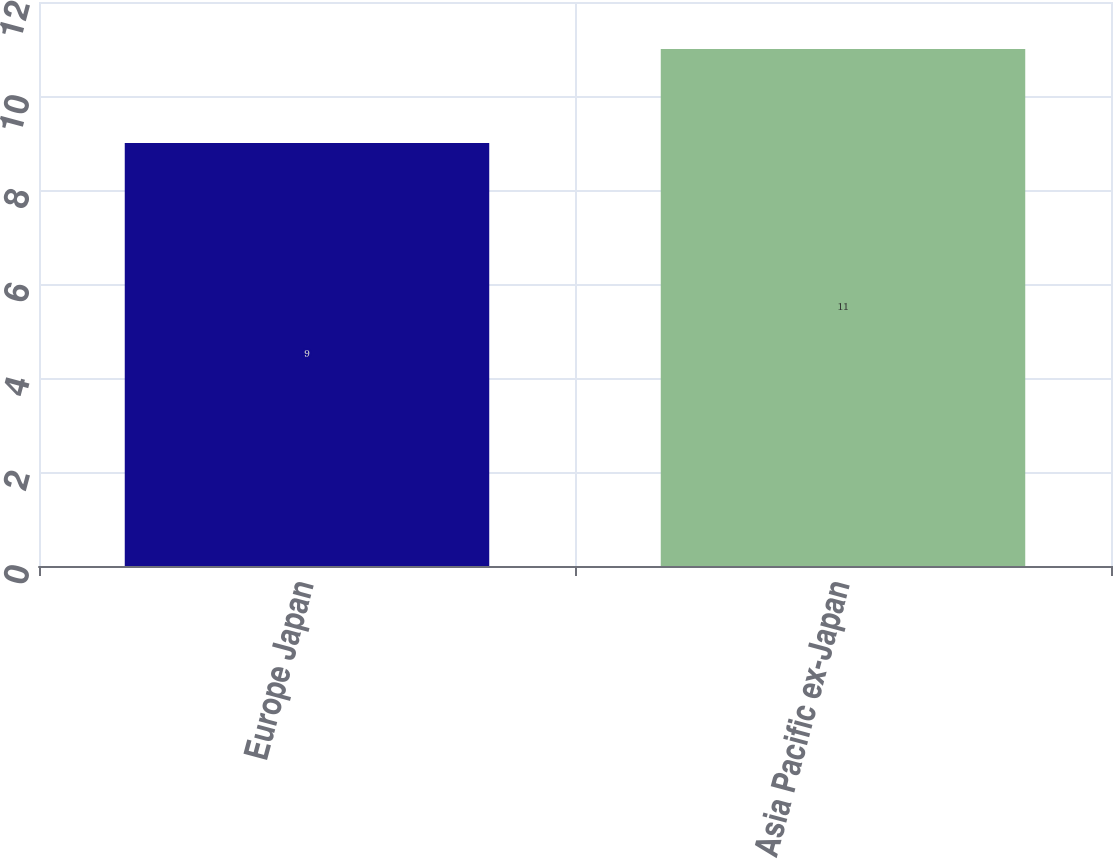Convert chart. <chart><loc_0><loc_0><loc_500><loc_500><bar_chart><fcel>Europe Japan<fcel>Asia Pacific ex-Japan<nl><fcel>9<fcel>11<nl></chart> 